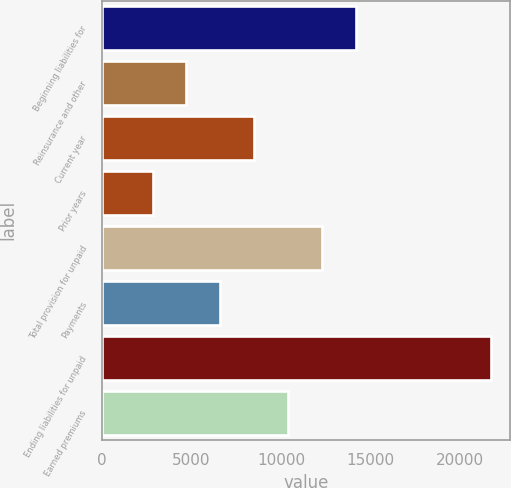Convert chart to OTSL. <chart><loc_0><loc_0><loc_500><loc_500><bar_chart><fcel>Beginning liabilities for<fcel>Reinsurance and other<fcel>Current year<fcel>Prior years<fcel>Total provision for unpaid<fcel>Payments<fcel>Ending liabilities for unpaid<fcel>Earned premiums<nl><fcel>14158.6<fcel>4713.1<fcel>8491.3<fcel>2824<fcel>12269.5<fcel>6602.2<fcel>21715<fcel>10380.4<nl></chart> 